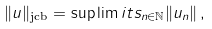Convert formula to latex. <formula><loc_0><loc_0><loc_500><loc_500>\| u \| _ { \text {jcb} } = \sup \lim i t s _ { n \in \mathbb { N } } \| u _ { n } \| \, ,</formula> 